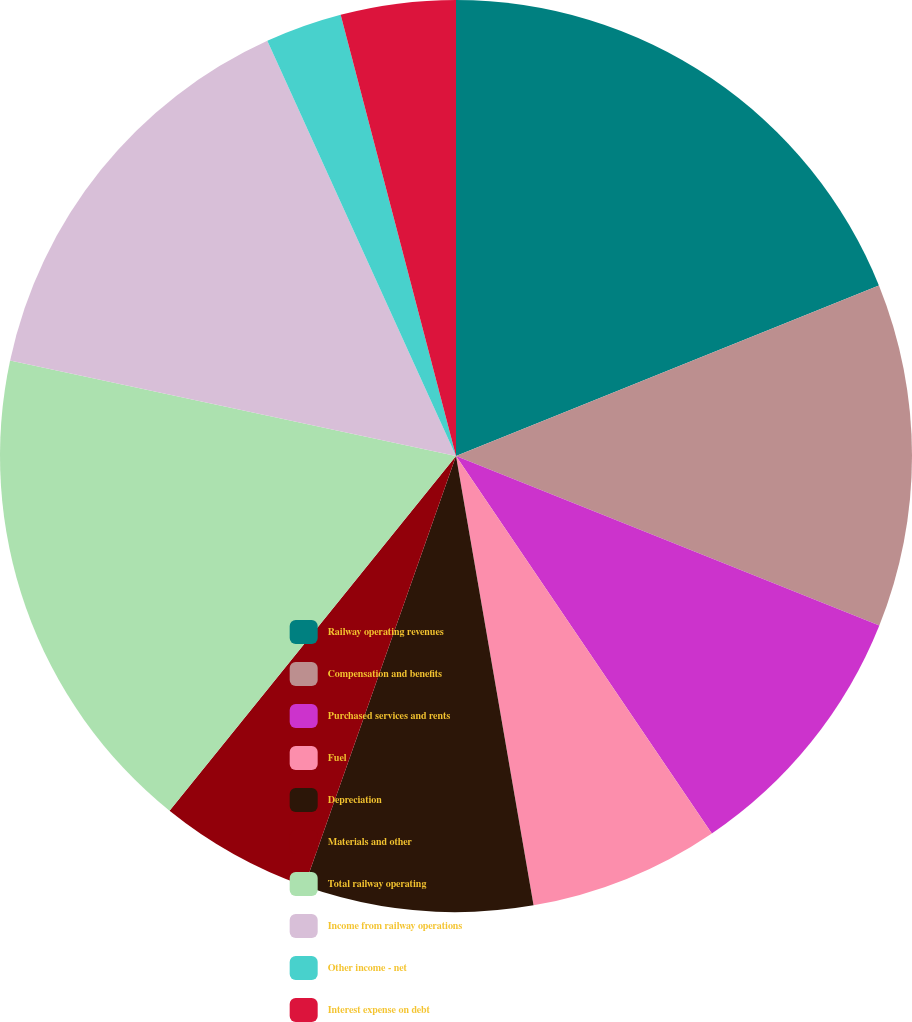<chart> <loc_0><loc_0><loc_500><loc_500><pie_chart><fcel>Railway operating revenues<fcel>Compensation and benefits<fcel>Purchased services and rents<fcel>Fuel<fcel>Depreciation<fcel>Materials and other<fcel>Total railway operating<fcel>Income from railway operations<fcel>Other income - net<fcel>Interest expense on debt<nl><fcel>18.9%<fcel>12.16%<fcel>9.46%<fcel>6.76%<fcel>8.11%<fcel>5.42%<fcel>17.55%<fcel>14.85%<fcel>2.72%<fcel>4.07%<nl></chart> 